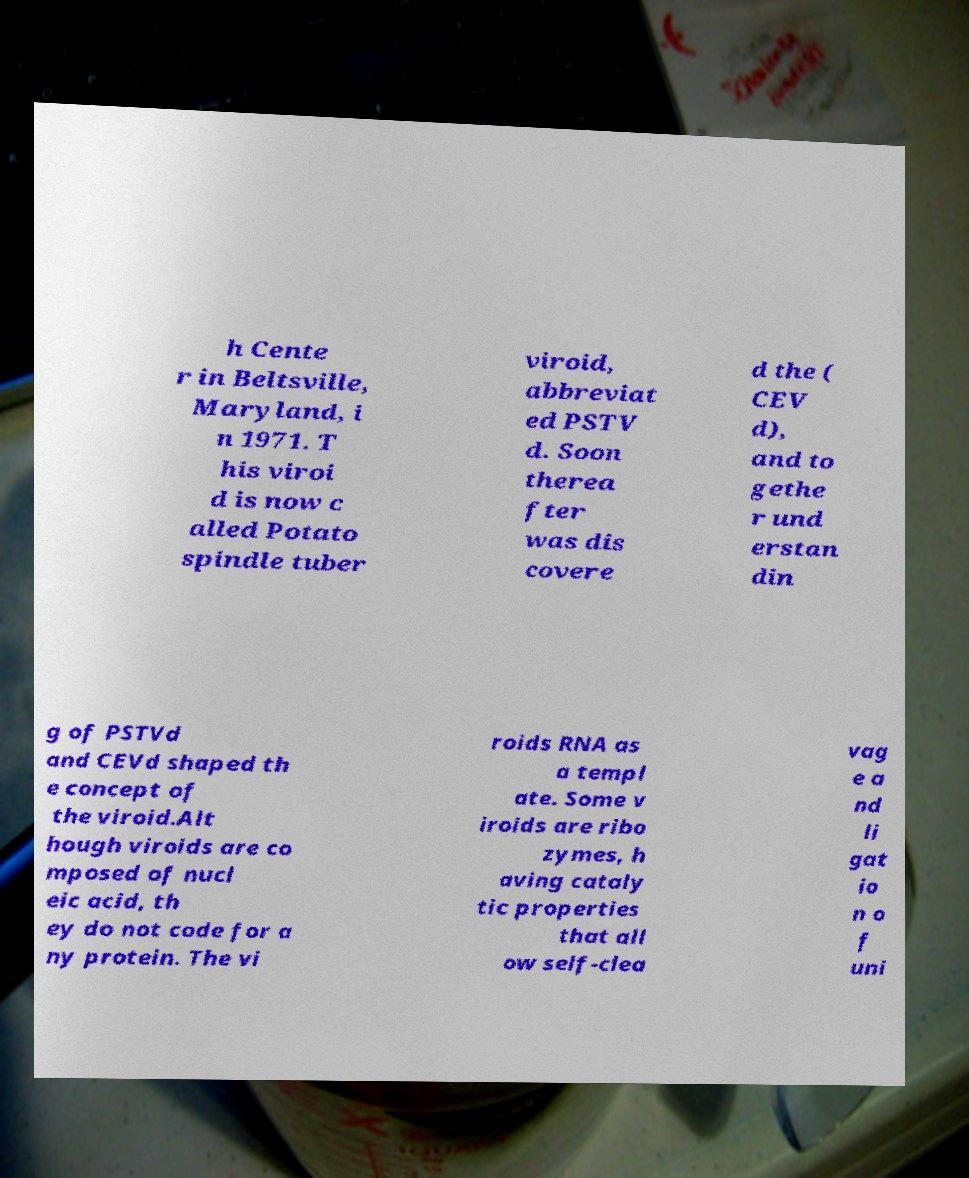Could you assist in decoding the text presented in this image and type it out clearly? h Cente r in Beltsville, Maryland, i n 1971. T his viroi d is now c alled Potato spindle tuber viroid, abbreviat ed PSTV d. Soon therea fter was dis covere d the ( CEV d), and to gethe r und erstan din g of PSTVd and CEVd shaped th e concept of the viroid.Alt hough viroids are co mposed of nucl eic acid, th ey do not code for a ny protein. The vi roids RNA as a templ ate. Some v iroids are ribo zymes, h aving cataly tic properties that all ow self-clea vag e a nd li gat io n o f uni 